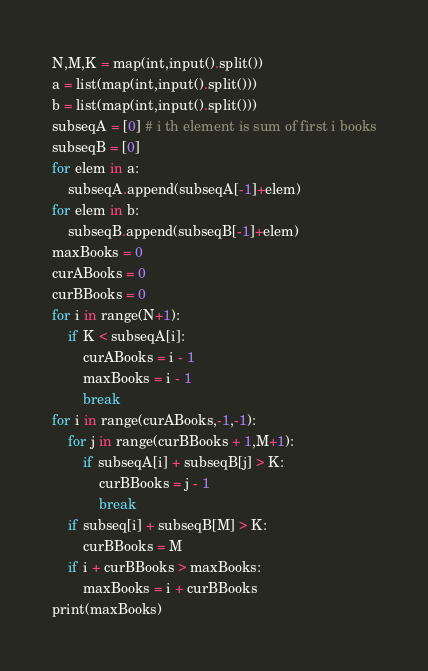<code> <loc_0><loc_0><loc_500><loc_500><_Python_>N,M,K = map(int,input().split())
a = list(map(int,input().split()))
b = list(map(int,input().split()))
subseqA = [0] # i th element is sum of first i books
subseqB = [0]
for elem in a:
    subseqA.append(subseqA[-1]+elem)
for elem in b:
    subseqB.append(subseqB[-1]+elem)
maxBooks = 0
curABooks = 0
curBBooks = 0
for i in range(N+1):
    if K < subseqA[i]:
        curABooks = i - 1
        maxBooks = i - 1
        break
for i in range(curABooks,-1,-1):
    for j in range(curBBooks + 1,M+1):
        if subseqA[i] + subseqB[j] > K:
            curBBooks = j - 1
            break
    if subseq[i] + subseqB[M] > K:
        curBBooks = M
    if i + curBBooks > maxBooks:
        maxBooks = i + curBBooks
print(maxBooks)</code> 